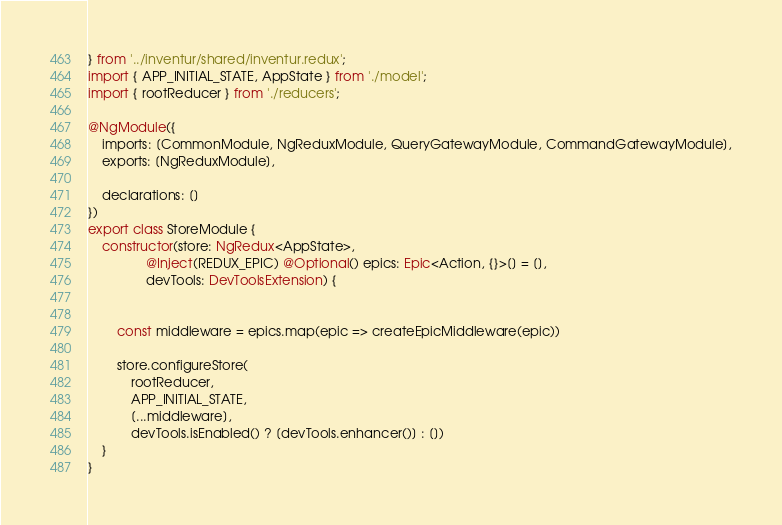Convert code to text. <code><loc_0><loc_0><loc_500><loc_500><_TypeScript_>} from '../inventur/shared/inventur.redux';
import { APP_INITIAL_STATE, AppState } from './model';
import { rootReducer } from './reducers';

@NgModule({
    imports: [CommonModule, NgReduxModule, QueryGatewayModule, CommandGatewayModule],
    exports: [NgReduxModule],

    declarations: []
})
export class StoreModule {
    constructor(store: NgRedux<AppState>,
                @Inject(REDUX_EPIC) @Optional() epics: Epic<Action, {}>[] = [],
                devTools: DevToolsExtension) {


        const middleware = epics.map(epic => createEpicMiddleware(epic))

        store.configureStore(
            rootReducer,
            APP_INITIAL_STATE,
            [...middleware],
            devTools.isEnabled() ? [devTools.enhancer()] : [])
    }
}
</code> 